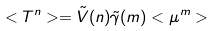<formula> <loc_0><loc_0><loc_500><loc_500>< T ^ { n } > = \tilde { V } ( n ) \tilde { \gamma } ( m ) < \mu ^ { m } ></formula> 